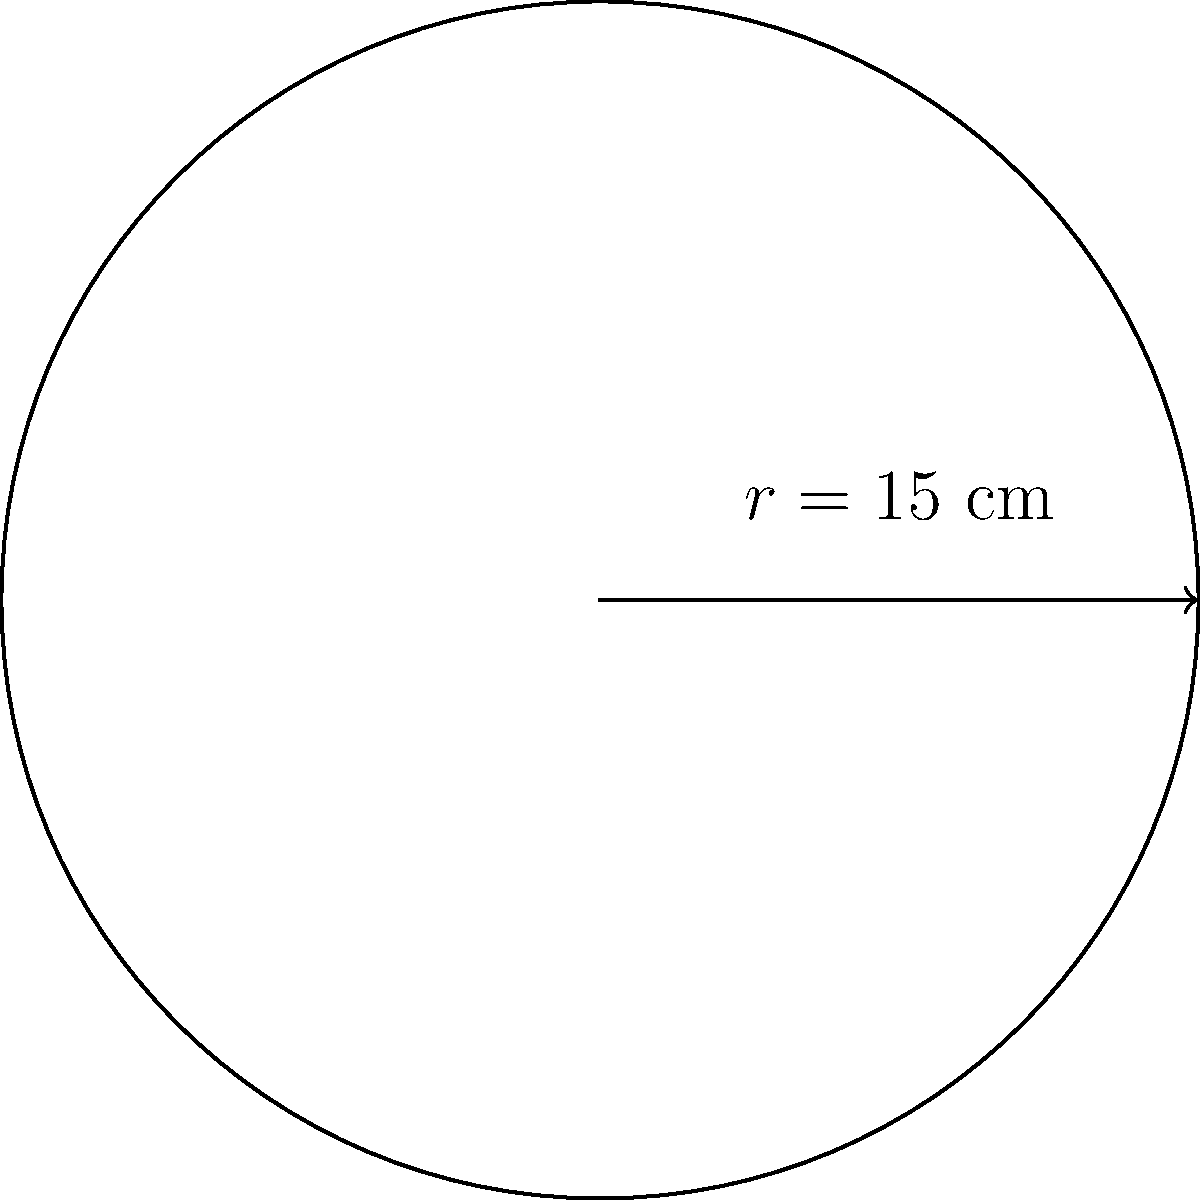You're teaching your 8-year-old student how to make a circular base for a woven basket. The base has a radius of 15 cm. What is the perimeter of this circular base? To find the perimeter of a circular base, we need to calculate its circumference. Here's how we do it:

1. The formula for the circumference of a circle is $C = 2\pi r$, where $r$ is the radius.

2. We're given that the radius is 15 cm.

3. Let's substitute this into our formula:
   $C = 2\pi \times 15$

4. $\pi$ is approximately 3.14159, but for simplicity, we'll use 3.14:
   $C = 2 \times 3.14 \times 15$

5. Now let's calculate:
   $C = 6.28 \times 15 = 94.2$ cm

6. Rounding to the nearest centimeter:
   $C \approx 94$ cm

So, the perimeter of the circular base for the woven basket is approximately 94 cm.
Answer: 94 cm 